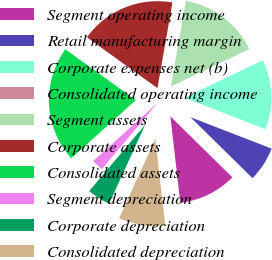Convert chart. <chart><loc_0><loc_0><loc_500><loc_500><pie_chart><fcel>Segment operating income<fcel>Retail manufacturing margin<fcel>Corporate expenses net (b)<fcel>Consolidated operating income<fcel>Segment assets<fcel>Corporate assets<fcel>Consolidated assets<fcel>Segment depreciation<fcel>Corporate depreciation<fcel>Consolidated depreciation<nl><fcel>10.81%<fcel>6.49%<fcel>12.97%<fcel>0.0%<fcel>15.14%<fcel>17.82%<fcel>21.62%<fcel>2.16%<fcel>4.33%<fcel>8.65%<nl></chart> 